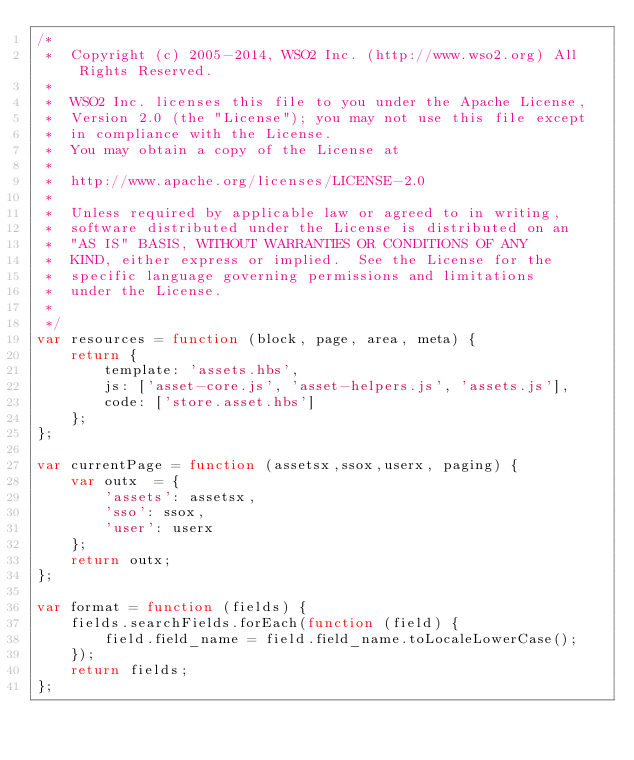<code> <loc_0><loc_0><loc_500><loc_500><_JavaScript_>/*
 *  Copyright (c) 2005-2014, WSO2 Inc. (http://www.wso2.org) All Rights Reserved.
 *
 *  WSO2 Inc. licenses this file to you under the Apache License,
 *  Version 2.0 (the "License"); you may not use this file except
 *  in compliance with the License.
 *  You may obtain a copy of the License at
 *
 *  http://www.apache.org/licenses/LICENSE-2.0
 *
 *  Unless required by applicable law or agreed to in writing,
 *  software distributed under the License is distributed on an
 *  "AS IS" BASIS, WITHOUT WARRANTIES OR CONDITIONS OF ANY
 *  KIND, either express or implied.  See the License for the
 *  specific language governing permissions and limitations
 *  under the License.
 *
 */
var resources = function (block, page, area, meta) {
    return {
        template: 'assets.hbs',
        js: ['asset-core.js', 'asset-helpers.js', 'assets.js'],
        code: ['store.asset.hbs']
    };
};

var currentPage = function (assetsx,ssox,userx, paging) {
    var outx  = {
        'assets': assetsx,
        'sso': ssox,
        'user': userx
    };
    return outx;
};

var format = function (fields) {
    fields.searchFields.forEach(function (field) {
        field.field_name = field.field_name.toLocaleLowerCase();
    });
    return fields;
};

</code> 